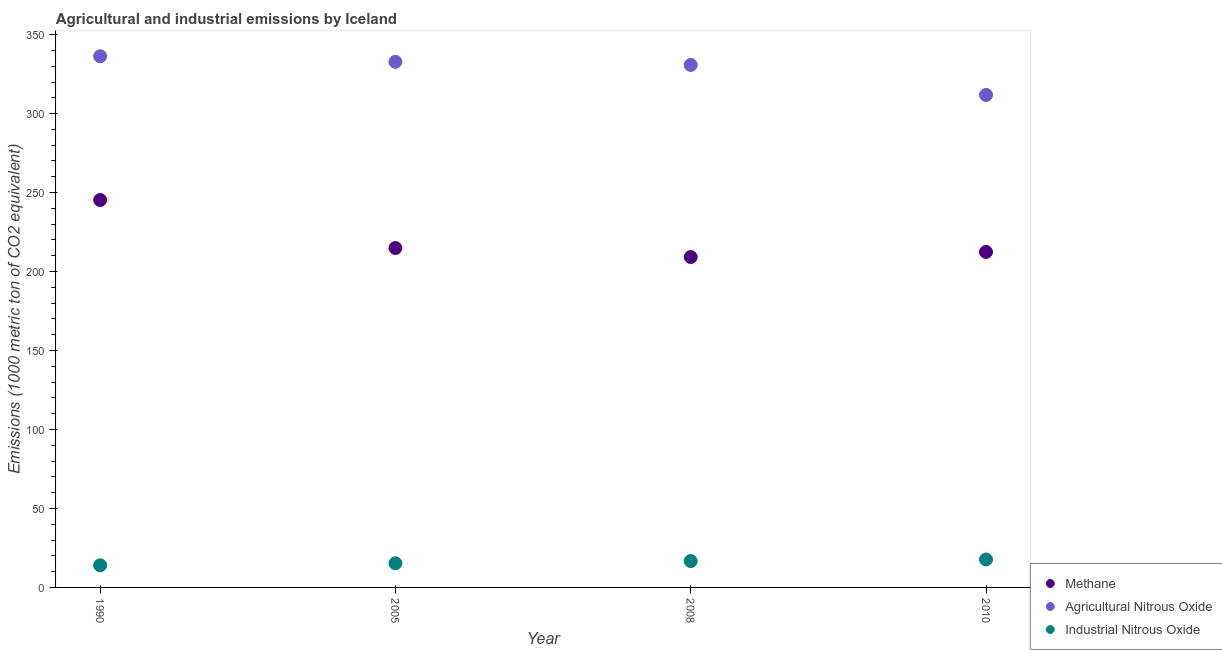What is the amount of industrial nitrous oxide emissions in 2005?
Your answer should be compact. 15.3. Across all years, what is the minimum amount of agricultural nitrous oxide emissions?
Give a very brief answer. 311.8. In which year was the amount of methane emissions maximum?
Your answer should be compact. 1990. In which year was the amount of agricultural nitrous oxide emissions minimum?
Give a very brief answer. 2010. What is the total amount of industrial nitrous oxide emissions in the graph?
Keep it short and to the point. 63.7. What is the difference between the amount of methane emissions in 2005 and that in 2008?
Your response must be concise. 5.7. What is the difference between the amount of methane emissions in 2005 and the amount of industrial nitrous oxide emissions in 2008?
Provide a short and direct response. 198.2. What is the average amount of methane emissions per year?
Keep it short and to the point. 220.45. In the year 2010, what is the difference between the amount of methane emissions and amount of agricultural nitrous oxide emissions?
Give a very brief answer. -99.4. What is the ratio of the amount of methane emissions in 1990 to that in 2005?
Provide a short and direct response. 1.14. What is the difference between the highest and the second highest amount of methane emissions?
Offer a terse response. 30.4. What is the difference between the highest and the lowest amount of industrial nitrous oxide emissions?
Provide a short and direct response. 3.7. In how many years, is the amount of industrial nitrous oxide emissions greater than the average amount of industrial nitrous oxide emissions taken over all years?
Offer a very short reply. 2. Is it the case that in every year, the sum of the amount of methane emissions and amount of agricultural nitrous oxide emissions is greater than the amount of industrial nitrous oxide emissions?
Provide a short and direct response. Yes. Is the amount of industrial nitrous oxide emissions strictly greater than the amount of agricultural nitrous oxide emissions over the years?
Ensure brevity in your answer.  No. How many years are there in the graph?
Offer a terse response. 4. What is the difference between two consecutive major ticks on the Y-axis?
Ensure brevity in your answer.  50. Does the graph contain grids?
Provide a succinct answer. No. What is the title of the graph?
Give a very brief answer. Agricultural and industrial emissions by Iceland. Does "Tertiary" appear as one of the legend labels in the graph?
Your answer should be compact. No. What is the label or title of the Y-axis?
Provide a short and direct response. Emissions (1000 metric ton of CO2 equivalent). What is the Emissions (1000 metric ton of CO2 equivalent) in Methane in 1990?
Ensure brevity in your answer.  245.3. What is the Emissions (1000 metric ton of CO2 equivalent) of Agricultural Nitrous Oxide in 1990?
Your answer should be compact. 336.3. What is the Emissions (1000 metric ton of CO2 equivalent) in Industrial Nitrous Oxide in 1990?
Ensure brevity in your answer.  14. What is the Emissions (1000 metric ton of CO2 equivalent) of Methane in 2005?
Keep it short and to the point. 214.9. What is the Emissions (1000 metric ton of CO2 equivalent) of Agricultural Nitrous Oxide in 2005?
Your answer should be very brief. 332.8. What is the Emissions (1000 metric ton of CO2 equivalent) in Methane in 2008?
Ensure brevity in your answer.  209.2. What is the Emissions (1000 metric ton of CO2 equivalent) in Agricultural Nitrous Oxide in 2008?
Ensure brevity in your answer.  330.8. What is the Emissions (1000 metric ton of CO2 equivalent) of Methane in 2010?
Your answer should be very brief. 212.4. What is the Emissions (1000 metric ton of CO2 equivalent) in Agricultural Nitrous Oxide in 2010?
Make the answer very short. 311.8. What is the Emissions (1000 metric ton of CO2 equivalent) in Industrial Nitrous Oxide in 2010?
Keep it short and to the point. 17.7. Across all years, what is the maximum Emissions (1000 metric ton of CO2 equivalent) in Methane?
Your response must be concise. 245.3. Across all years, what is the maximum Emissions (1000 metric ton of CO2 equivalent) in Agricultural Nitrous Oxide?
Offer a terse response. 336.3. Across all years, what is the maximum Emissions (1000 metric ton of CO2 equivalent) of Industrial Nitrous Oxide?
Offer a terse response. 17.7. Across all years, what is the minimum Emissions (1000 metric ton of CO2 equivalent) in Methane?
Give a very brief answer. 209.2. Across all years, what is the minimum Emissions (1000 metric ton of CO2 equivalent) in Agricultural Nitrous Oxide?
Your response must be concise. 311.8. What is the total Emissions (1000 metric ton of CO2 equivalent) of Methane in the graph?
Ensure brevity in your answer.  881.8. What is the total Emissions (1000 metric ton of CO2 equivalent) in Agricultural Nitrous Oxide in the graph?
Offer a very short reply. 1311.7. What is the total Emissions (1000 metric ton of CO2 equivalent) of Industrial Nitrous Oxide in the graph?
Your response must be concise. 63.7. What is the difference between the Emissions (1000 metric ton of CO2 equivalent) in Methane in 1990 and that in 2005?
Your answer should be very brief. 30.4. What is the difference between the Emissions (1000 metric ton of CO2 equivalent) in Industrial Nitrous Oxide in 1990 and that in 2005?
Provide a short and direct response. -1.3. What is the difference between the Emissions (1000 metric ton of CO2 equivalent) in Methane in 1990 and that in 2008?
Your response must be concise. 36.1. What is the difference between the Emissions (1000 metric ton of CO2 equivalent) in Industrial Nitrous Oxide in 1990 and that in 2008?
Provide a succinct answer. -2.7. What is the difference between the Emissions (1000 metric ton of CO2 equivalent) of Methane in 1990 and that in 2010?
Keep it short and to the point. 32.9. What is the difference between the Emissions (1000 metric ton of CO2 equivalent) in Industrial Nitrous Oxide in 1990 and that in 2010?
Your response must be concise. -3.7. What is the difference between the Emissions (1000 metric ton of CO2 equivalent) in Methane in 2005 and that in 2008?
Provide a succinct answer. 5.7. What is the difference between the Emissions (1000 metric ton of CO2 equivalent) of Agricultural Nitrous Oxide in 2005 and that in 2010?
Give a very brief answer. 21. What is the difference between the Emissions (1000 metric ton of CO2 equivalent) in Agricultural Nitrous Oxide in 2008 and that in 2010?
Your answer should be very brief. 19. What is the difference between the Emissions (1000 metric ton of CO2 equivalent) in Methane in 1990 and the Emissions (1000 metric ton of CO2 equivalent) in Agricultural Nitrous Oxide in 2005?
Offer a terse response. -87.5. What is the difference between the Emissions (1000 metric ton of CO2 equivalent) of Methane in 1990 and the Emissions (1000 metric ton of CO2 equivalent) of Industrial Nitrous Oxide in 2005?
Give a very brief answer. 230. What is the difference between the Emissions (1000 metric ton of CO2 equivalent) in Agricultural Nitrous Oxide in 1990 and the Emissions (1000 metric ton of CO2 equivalent) in Industrial Nitrous Oxide in 2005?
Provide a succinct answer. 321. What is the difference between the Emissions (1000 metric ton of CO2 equivalent) in Methane in 1990 and the Emissions (1000 metric ton of CO2 equivalent) in Agricultural Nitrous Oxide in 2008?
Your response must be concise. -85.5. What is the difference between the Emissions (1000 metric ton of CO2 equivalent) of Methane in 1990 and the Emissions (1000 metric ton of CO2 equivalent) of Industrial Nitrous Oxide in 2008?
Your answer should be very brief. 228.6. What is the difference between the Emissions (1000 metric ton of CO2 equivalent) of Agricultural Nitrous Oxide in 1990 and the Emissions (1000 metric ton of CO2 equivalent) of Industrial Nitrous Oxide in 2008?
Your response must be concise. 319.6. What is the difference between the Emissions (1000 metric ton of CO2 equivalent) in Methane in 1990 and the Emissions (1000 metric ton of CO2 equivalent) in Agricultural Nitrous Oxide in 2010?
Provide a short and direct response. -66.5. What is the difference between the Emissions (1000 metric ton of CO2 equivalent) of Methane in 1990 and the Emissions (1000 metric ton of CO2 equivalent) of Industrial Nitrous Oxide in 2010?
Your answer should be compact. 227.6. What is the difference between the Emissions (1000 metric ton of CO2 equivalent) in Agricultural Nitrous Oxide in 1990 and the Emissions (1000 metric ton of CO2 equivalent) in Industrial Nitrous Oxide in 2010?
Offer a very short reply. 318.6. What is the difference between the Emissions (1000 metric ton of CO2 equivalent) in Methane in 2005 and the Emissions (1000 metric ton of CO2 equivalent) in Agricultural Nitrous Oxide in 2008?
Provide a succinct answer. -115.9. What is the difference between the Emissions (1000 metric ton of CO2 equivalent) of Methane in 2005 and the Emissions (1000 metric ton of CO2 equivalent) of Industrial Nitrous Oxide in 2008?
Your answer should be very brief. 198.2. What is the difference between the Emissions (1000 metric ton of CO2 equivalent) of Agricultural Nitrous Oxide in 2005 and the Emissions (1000 metric ton of CO2 equivalent) of Industrial Nitrous Oxide in 2008?
Make the answer very short. 316.1. What is the difference between the Emissions (1000 metric ton of CO2 equivalent) of Methane in 2005 and the Emissions (1000 metric ton of CO2 equivalent) of Agricultural Nitrous Oxide in 2010?
Offer a very short reply. -96.9. What is the difference between the Emissions (1000 metric ton of CO2 equivalent) in Methane in 2005 and the Emissions (1000 metric ton of CO2 equivalent) in Industrial Nitrous Oxide in 2010?
Offer a terse response. 197.2. What is the difference between the Emissions (1000 metric ton of CO2 equivalent) of Agricultural Nitrous Oxide in 2005 and the Emissions (1000 metric ton of CO2 equivalent) of Industrial Nitrous Oxide in 2010?
Give a very brief answer. 315.1. What is the difference between the Emissions (1000 metric ton of CO2 equivalent) of Methane in 2008 and the Emissions (1000 metric ton of CO2 equivalent) of Agricultural Nitrous Oxide in 2010?
Your response must be concise. -102.6. What is the difference between the Emissions (1000 metric ton of CO2 equivalent) of Methane in 2008 and the Emissions (1000 metric ton of CO2 equivalent) of Industrial Nitrous Oxide in 2010?
Your answer should be compact. 191.5. What is the difference between the Emissions (1000 metric ton of CO2 equivalent) in Agricultural Nitrous Oxide in 2008 and the Emissions (1000 metric ton of CO2 equivalent) in Industrial Nitrous Oxide in 2010?
Give a very brief answer. 313.1. What is the average Emissions (1000 metric ton of CO2 equivalent) of Methane per year?
Offer a very short reply. 220.45. What is the average Emissions (1000 metric ton of CO2 equivalent) in Agricultural Nitrous Oxide per year?
Keep it short and to the point. 327.93. What is the average Emissions (1000 metric ton of CO2 equivalent) in Industrial Nitrous Oxide per year?
Provide a succinct answer. 15.93. In the year 1990, what is the difference between the Emissions (1000 metric ton of CO2 equivalent) of Methane and Emissions (1000 metric ton of CO2 equivalent) of Agricultural Nitrous Oxide?
Your response must be concise. -91. In the year 1990, what is the difference between the Emissions (1000 metric ton of CO2 equivalent) of Methane and Emissions (1000 metric ton of CO2 equivalent) of Industrial Nitrous Oxide?
Ensure brevity in your answer.  231.3. In the year 1990, what is the difference between the Emissions (1000 metric ton of CO2 equivalent) of Agricultural Nitrous Oxide and Emissions (1000 metric ton of CO2 equivalent) of Industrial Nitrous Oxide?
Ensure brevity in your answer.  322.3. In the year 2005, what is the difference between the Emissions (1000 metric ton of CO2 equivalent) in Methane and Emissions (1000 metric ton of CO2 equivalent) in Agricultural Nitrous Oxide?
Provide a succinct answer. -117.9. In the year 2005, what is the difference between the Emissions (1000 metric ton of CO2 equivalent) of Methane and Emissions (1000 metric ton of CO2 equivalent) of Industrial Nitrous Oxide?
Give a very brief answer. 199.6. In the year 2005, what is the difference between the Emissions (1000 metric ton of CO2 equivalent) of Agricultural Nitrous Oxide and Emissions (1000 metric ton of CO2 equivalent) of Industrial Nitrous Oxide?
Provide a succinct answer. 317.5. In the year 2008, what is the difference between the Emissions (1000 metric ton of CO2 equivalent) of Methane and Emissions (1000 metric ton of CO2 equivalent) of Agricultural Nitrous Oxide?
Offer a very short reply. -121.6. In the year 2008, what is the difference between the Emissions (1000 metric ton of CO2 equivalent) in Methane and Emissions (1000 metric ton of CO2 equivalent) in Industrial Nitrous Oxide?
Ensure brevity in your answer.  192.5. In the year 2008, what is the difference between the Emissions (1000 metric ton of CO2 equivalent) in Agricultural Nitrous Oxide and Emissions (1000 metric ton of CO2 equivalent) in Industrial Nitrous Oxide?
Your response must be concise. 314.1. In the year 2010, what is the difference between the Emissions (1000 metric ton of CO2 equivalent) in Methane and Emissions (1000 metric ton of CO2 equivalent) in Agricultural Nitrous Oxide?
Provide a short and direct response. -99.4. In the year 2010, what is the difference between the Emissions (1000 metric ton of CO2 equivalent) in Methane and Emissions (1000 metric ton of CO2 equivalent) in Industrial Nitrous Oxide?
Keep it short and to the point. 194.7. In the year 2010, what is the difference between the Emissions (1000 metric ton of CO2 equivalent) of Agricultural Nitrous Oxide and Emissions (1000 metric ton of CO2 equivalent) of Industrial Nitrous Oxide?
Provide a succinct answer. 294.1. What is the ratio of the Emissions (1000 metric ton of CO2 equivalent) of Methane in 1990 to that in 2005?
Keep it short and to the point. 1.14. What is the ratio of the Emissions (1000 metric ton of CO2 equivalent) in Agricultural Nitrous Oxide in 1990 to that in 2005?
Make the answer very short. 1.01. What is the ratio of the Emissions (1000 metric ton of CO2 equivalent) of Industrial Nitrous Oxide in 1990 to that in 2005?
Your answer should be very brief. 0.92. What is the ratio of the Emissions (1000 metric ton of CO2 equivalent) in Methane in 1990 to that in 2008?
Ensure brevity in your answer.  1.17. What is the ratio of the Emissions (1000 metric ton of CO2 equivalent) in Agricultural Nitrous Oxide in 1990 to that in 2008?
Provide a short and direct response. 1.02. What is the ratio of the Emissions (1000 metric ton of CO2 equivalent) of Industrial Nitrous Oxide in 1990 to that in 2008?
Offer a terse response. 0.84. What is the ratio of the Emissions (1000 metric ton of CO2 equivalent) of Methane in 1990 to that in 2010?
Make the answer very short. 1.15. What is the ratio of the Emissions (1000 metric ton of CO2 equivalent) of Agricultural Nitrous Oxide in 1990 to that in 2010?
Provide a succinct answer. 1.08. What is the ratio of the Emissions (1000 metric ton of CO2 equivalent) of Industrial Nitrous Oxide in 1990 to that in 2010?
Offer a terse response. 0.79. What is the ratio of the Emissions (1000 metric ton of CO2 equivalent) in Methane in 2005 to that in 2008?
Give a very brief answer. 1.03. What is the ratio of the Emissions (1000 metric ton of CO2 equivalent) of Industrial Nitrous Oxide in 2005 to that in 2008?
Ensure brevity in your answer.  0.92. What is the ratio of the Emissions (1000 metric ton of CO2 equivalent) in Methane in 2005 to that in 2010?
Your response must be concise. 1.01. What is the ratio of the Emissions (1000 metric ton of CO2 equivalent) in Agricultural Nitrous Oxide in 2005 to that in 2010?
Provide a short and direct response. 1.07. What is the ratio of the Emissions (1000 metric ton of CO2 equivalent) in Industrial Nitrous Oxide in 2005 to that in 2010?
Give a very brief answer. 0.86. What is the ratio of the Emissions (1000 metric ton of CO2 equivalent) of Methane in 2008 to that in 2010?
Offer a terse response. 0.98. What is the ratio of the Emissions (1000 metric ton of CO2 equivalent) of Agricultural Nitrous Oxide in 2008 to that in 2010?
Give a very brief answer. 1.06. What is the ratio of the Emissions (1000 metric ton of CO2 equivalent) of Industrial Nitrous Oxide in 2008 to that in 2010?
Your answer should be compact. 0.94. What is the difference between the highest and the second highest Emissions (1000 metric ton of CO2 equivalent) in Methane?
Offer a very short reply. 30.4. What is the difference between the highest and the second highest Emissions (1000 metric ton of CO2 equivalent) of Agricultural Nitrous Oxide?
Your response must be concise. 3.5. What is the difference between the highest and the lowest Emissions (1000 metric ton of CO2 equivalent) in Methane?
Your answer should be compact. 36.1. 